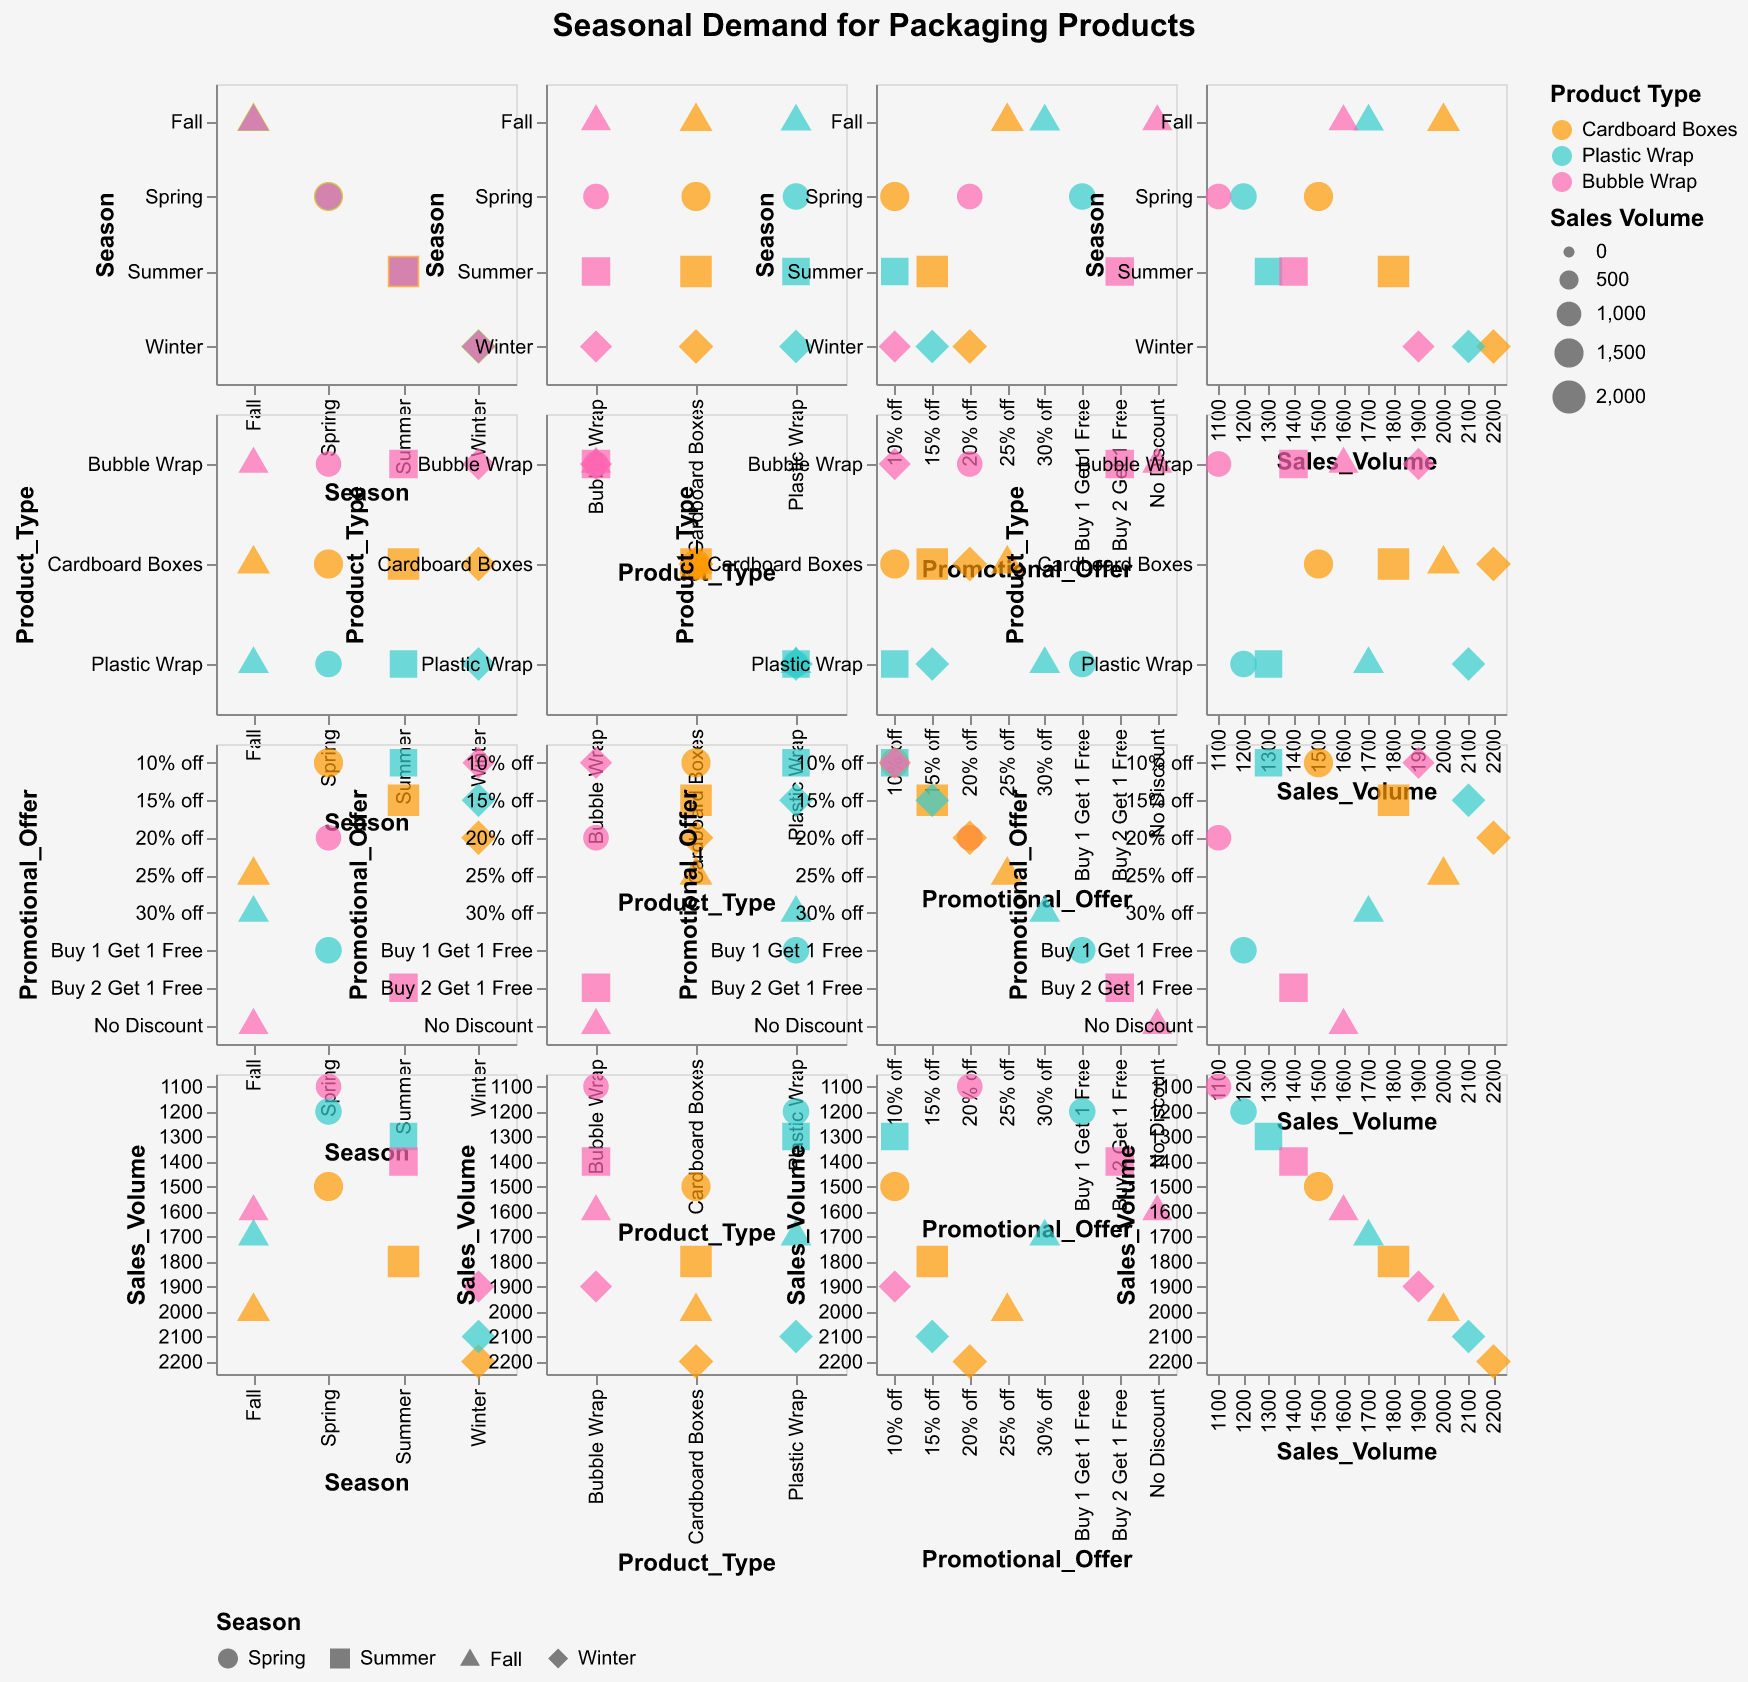How many data points are displayed in the Scatter Plot Matrix? To determine the number of data points, count each unique combination of values from the data provided. There are four seasonal records for each product type and promotional offer combination, resulting in 12 total points.
Answer: 12 Which product type has the highest sales volume in the Winter season? Check the sales volumes for Winter across all product types. Cardboard Boxes have the highest value at 2200.
Answer: Cardboard Boxes Is there any product type that shows a decrease in sales volume from Summer to Fall? Compare sales volumes for each product type between Summer and Fall. Cardboard Boxes: 1800 to 2000 (increase), Plastic Wrap: 1300 to 1700 (increase), Bubble Wrap: 1400 to 1600 (increase). No product type shows a decrease.
Answer: No What is the promotional offer that corresponds to the highest sales volume in the Fall season? Identify the promotional offers and compare sales volumes for Fall season. The highest sales volume (2000) for Fall has a 25% off offer.
Answer: 25% off Which season has the least variation in sales volume for Cardboard Boxes? Observe the spread of sales volume values for Cardboard Boxes across all seasons to identify which one has the smallest range. Spring: 1500, Summer: 1800, Fall: 2000, Winter: 2200. Spring has the smallest variation.
Answer: Spring Do sales for Bubble Wrap increase or decrease from Spring to Winter? Compare the sales volume for Bubble Wrap in the Spring and Winter. Spring has 1100, and Winter has 1900, indicating an increase.
Answer: Increase Which product type has the most diverse set of promotional offers? Review the number of unique promotional offers for each product type across the dataset. Each type has three distinct promotional offers, but without further context, all show diverse offers.
Answer: All product types By observing the scatter plot matrix, can we infer if promotional offers significantly impact sales volume? Analyze the clusters formed in the scatter plot matrix. Generally, higher sales volumes correspond to some discount offers, indicating a potential positive impact.
Answer: Yes Which combination of season and promotional offer corresponds to the highest sales volume overall? Identify the highest sales volume data point and check its corresponding season and promotional offer. Winter with 20% off has the highest sales volume of 2200.
Answer: Winter, 20% off 